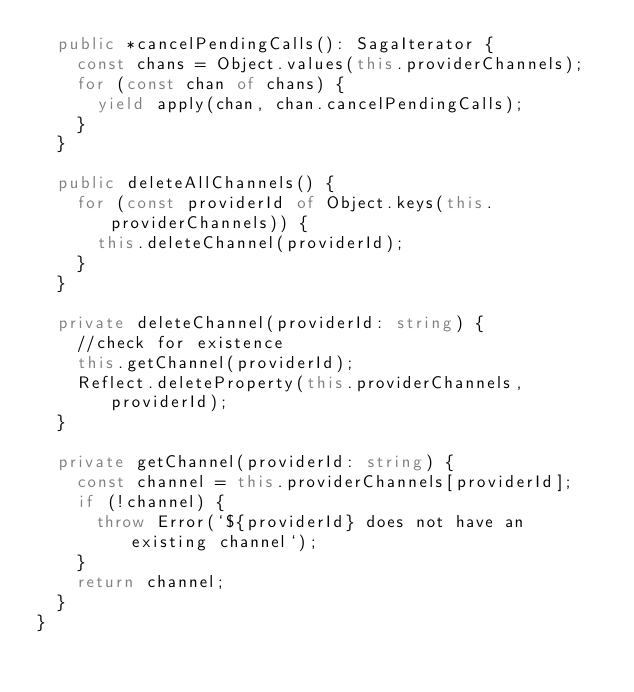<code> <loc_0><loc_0><loc_500><loc_500><_TypeScript_>  public *cancelPendingCalls(): SagaIterator {
    const chans = Object.values(this.providerChannels);
    for (const chan of chans) {
      yield apply(chan, chan.cancelPendingCalls);
    }
  }

  public deleteAllChannels() {
    for (const providerId of Object.keys(this.providerChannels)) {
      this.deleteChannel(providerId);
    }
  }

  private deleteChannel(providerId: string) {
    //check for existence
    this.getChannel(providerId);
    Reflect.deleteProperty(this.providerChannels, providerId);
  }

  private getChannel(providerId: string) {
    const channel = this.providerChannels[providerId];
    if (!channel) {
      throw Error(`${providerId} does not have an existing channel`);
    }
    return channel;
  }
}
</code> 